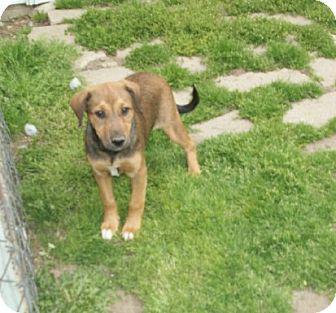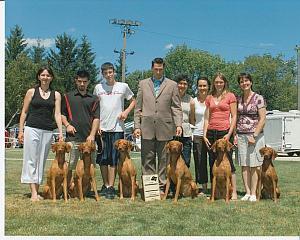The first image is the image on the left, the second image is the image on the right. Given the left and right images, does the statement "The combined images contain no more than three dogs, and at least two dogs are standing on all fours." hold true? Answer yes or no. No. The first image is the image on the left, the second image is the image on the right. Evaluate the accuracy of this statement regarding the images: "The left and right image contains the same number of dogs.". Is it true? Answer yes or no. No. 